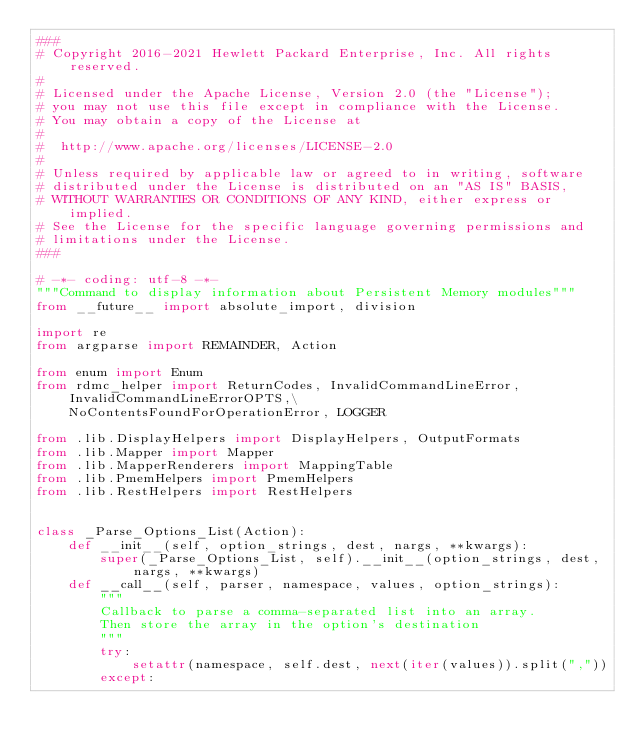Convert code to text. <code><loc_0><loc_0><loc_500><loc_500><_Python_>###
# Copyright 2016-2021 Hewlett Packard Enterprise, Inc. All rights reserved.
#
# Licensed under the Apache License, Version 2.0 (the "License");
# you may not use this file except in compliance with the License.
# You may obtain a copy of the License at
#
#  http://www.apache.org/licenses/LICENSE-2.0
#
# Unless required by applicable law or agreed to in writing, software
# distributed under the License is distributed on an "AS IS" BASIS,
# WITHOUT WARRANTIES OR CONDITIONS OF ANY KIND, either express or implied.
# See the License for the specific language governing permissions and
# limitations under the License.
###

# -*- coding: utf-8 -*-
"""Command to display information about Persistent Memory modules"""
from __future__ import absolute_import, division

import re
from argparse import REMAINDER, Action

from enum import Enum
from rdmc_helper import ReturnCodes, InvalidCommandLineError, InvalidCommandLineErrorOPTS,\
    NoContentsFoundForOperationError, LOGGER

from .lib.DisplayHelpers import DisplayHelpers, OutputFormats
from .lib.Mapper import Mapper
from .lib.MapperRenderers import MappingTable
from .lib.PmemHelpers import PmemHelpers
from .lib.RestHelpers import RestHelpers


class _Parse_Options_List(Action):
    def __init__(self, option_strings, dest, nargs, **kwargs):
        super(_Parse_Options_List, self).__init__(option_strings, dest, nargs, **kwargs)
    def __call__(self, parser, namespace, values, option_strings):
        """
        Callback to parse a comma-separated list into an array.
        Then store the array in the option's destination
        """
        try:
            setattr(namespace, self.dest, next(iter(values)).split(","))
        except:</code> 